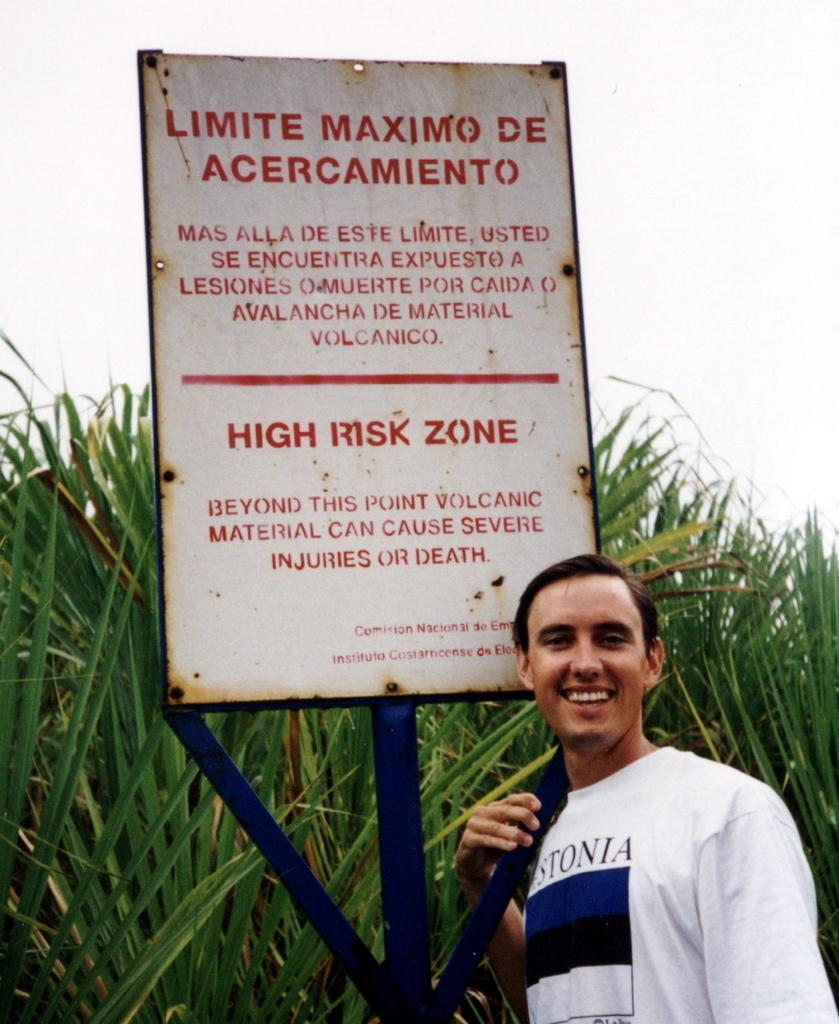<image>
Offer a succinct explanation of the picture presented. A man poses beneath a sign explaining the dangers of the volcanic area. 